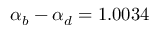<formula> <loc_0><loc_0><loc_500><loc_500>\alpha _ { b } - \alpha _ { d } = 1 . 0 0 3 4</formula> 